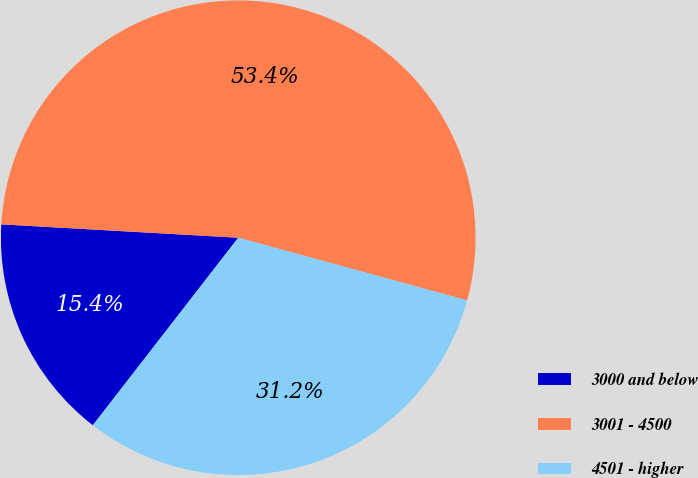Convert chart to OTSL. <chart><loc_0><loc_0><loc_500><loc_500><pie_chart><fcel>3000 and below<fcel>3001 - 4500<fcel>4501 - higher<nl><fcel>15.4%<fcel>53.36%<fcel>31.24%<nl></chart> 